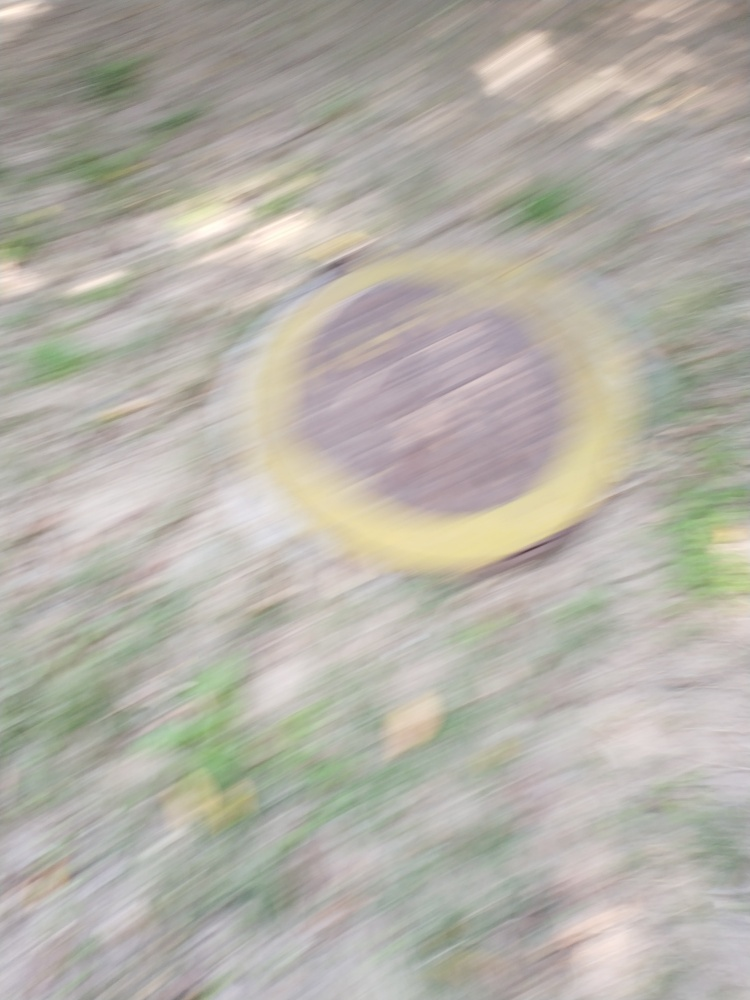If I wanted a similar effect but with a clearer subject, how might I achieve that? To achieve a motion blur effect while keeping the subject clear, you could use a technique called 'panning'. This involves moving the camera along with the subject at the same speed, keeping the subject in the same position of the frame for the duration of the exposure. This results in a sharp subject against a blurred background, conveying movement. 